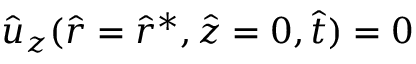Convert formula to latex. <formula><loc_0><loc_0><loc_500><loc_500>\hat { u } _ { z } ( \hat { r } = \hat { r } ^ { * } , \hat { z } = 0 , \hat { t } ) = 0</formula> 